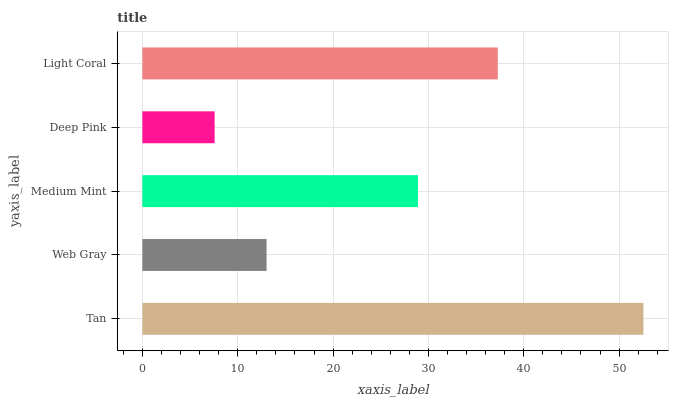Is Deep Pink the minimum?
Answer yes or no. Yes. Is Tan the maximum?
Answer yes or no. Yes. Is Web Gray the minimum?
Answer yes or no. No. Is Web Gray the maximum?
Answer yes or no. No. Is Tan greater than Web Gray?
Answer yes or no. Yes. Is Web Gray less than Tan?
Answer yes or no. Yes. Is Web Gray greater than Tan?
Answer yes or no. No. Is Tan less than Web Gray?
Answer yes or no. No. Is Medium Mint the high median?
Answer yes or no. Yes. Is Medium Mint the low median?
Answer yes or no. Yes. Is Tan the high median?
Answer yes or no. No. Is Light Coral the low median?
Answer yes or no. No. 